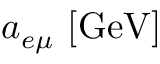Convert formula to latex. <formula><loc_0><loc_0><loc_500><loc_500>a _ { e \mu } [ G e V ]</formula> 